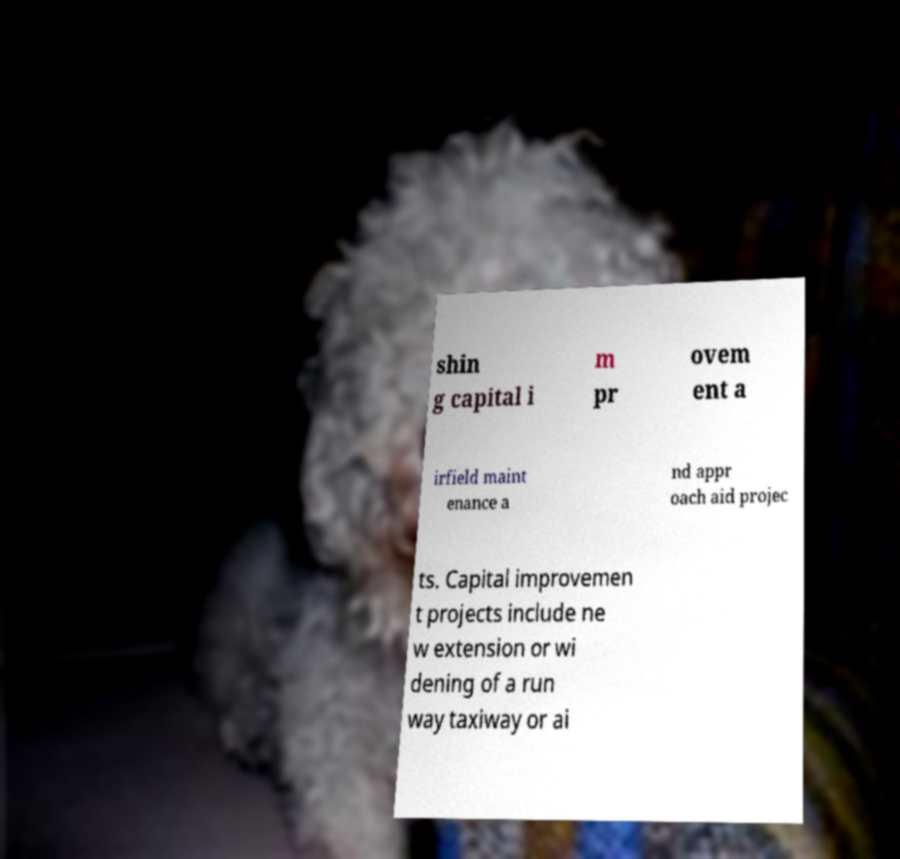There's text embedded in this image that I need extracted. Can you transcribe it verbatim? shin g capital i m pr ovem ent a irfield maint enance a nd appr oach aid projec ts. Capital improvemen t projects include ne w extension or wi dening of a run way taxiway or ai 